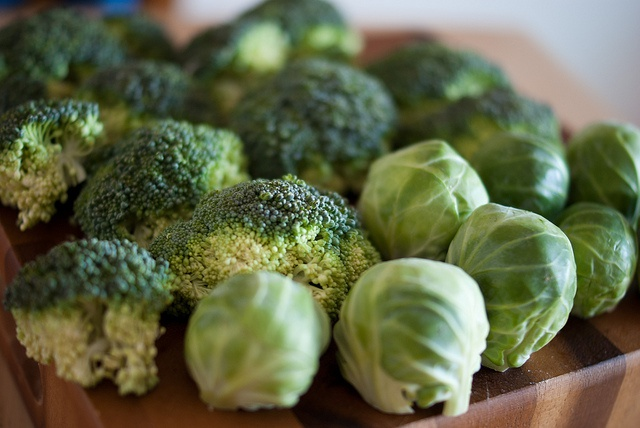Describe the objects in this image and their specific colors. I can see broccoli in navy, darkgreen, black, and olive tones, broccoli in navy, black, olive, and darkgreen tones, broccoli in navy, black, teal, and darkgreen tones, broccoli in navy, black, and darkgreen tones, and broccoli in navy, black, and darkgreen tones in this image. 